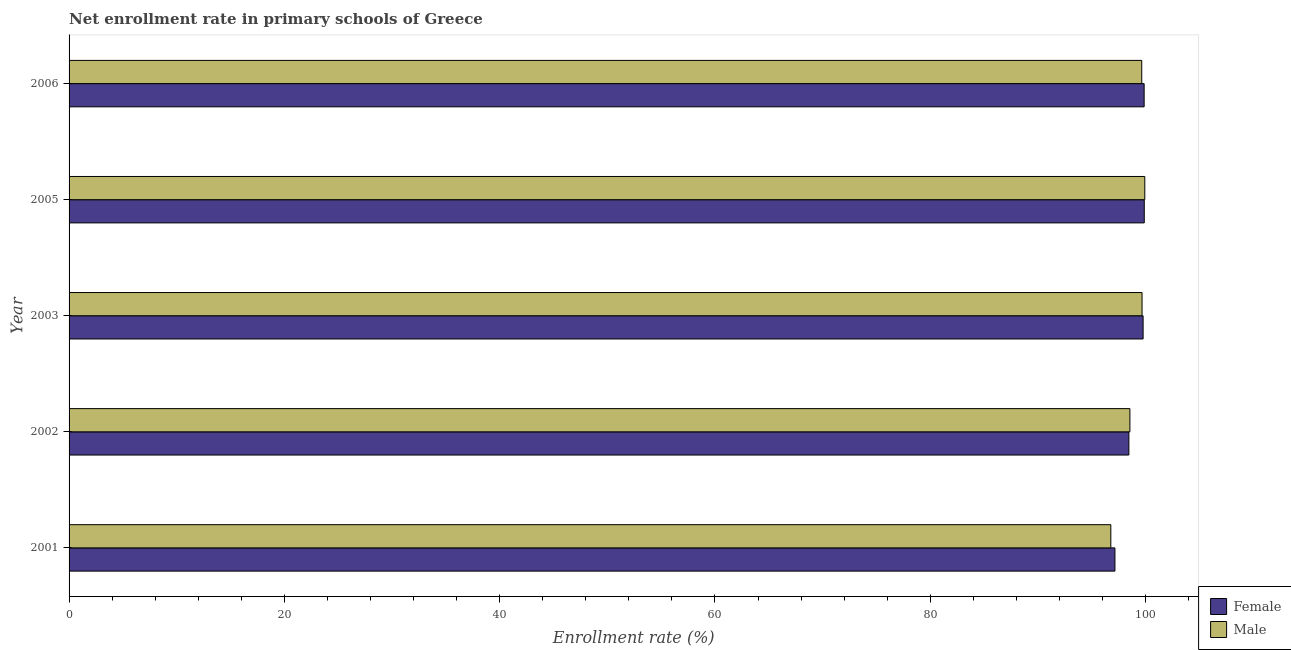How many different coloured bars are there?
Make the answer very short. 2. Are the number of bars on each tick of the Y-axis equal?
Ensure brevity in your answer.  Yes. How many bars are there on the 5th tick from the bottom?
Your response must be concise. 2. What is the label of the 5th group of bars from the top?
Keep it short and to the point. 2001. In how many cases, is the number of bars for a given year not equal to the number of legend labels?
Your response must be concise. 0. What is the enrollment rate of female students in 2005?
Offer a very short reply. 99.88. Across all years, what is the maximum enrollment rate of male students?
Your answer should be compact. 99.93. Across all years, what is the minimum enrollment rate of female students?
Your response must be concise. 97.15. In which year was the enrollment rate of male students minimum?
Your answer should be compact. 2001. What is the total enrollment rate of male students in the graph?
Provide a short and direct response. 494.55. What is the difference between the enrollment rate of female students in 2002 and that in 2005?
Your response must be concise. -1.43. What is the difference between the enrollment rate of male students in 2002 and the enrollment rate of female students in 2005?
Make the answer very short. -1.33. What is the average enrollment rate of female students per year?
Provide a succinct answer. 99.02. In the year 2003, what is the difference between the enrollment rate of female students and enrollment rate of male students?
Give a very brief answer. 0.1. What is the ratio of the enrollment rate of male students in 2003 to that in 2005?
Give a very brief answer. 1. Is the enrollment rate of male students in 2001 less than that in 2003?
Your answer should be very brief. Yes. What is the difference between the highest and the second highest enrollment rate of male students?
Provide a short and direct response. 0.26. What is the difference between the highest and the lowest enrollment rate of male students?
Ensure brevity in your answer.  3.16. In how many years, is the enrollment rate of male students greater than the average enrollment rate of male students taken over all years?
Give a very brief answer. 3. Is the sum of the enrollment rate of female students in 2001 and 2006 greater than the maximum enrollment rate of male students across all years?
Provide a short and direct response. Yes. What does the 2nd bar from the top in 2003 represents?
Give a very brief answer. Female. What does the 2nd bar from the bottom in 2001 represents?
Offer a terse response. Male. How many years are there in the graph?
Make the answer very short. 5. Are the values on the major ticks of X-axis written in scientific E-notation?
Ensure brevity in your answer.  No. Does the graph contain any zero values?
Your answer should be very brief. No. Where does the legend appear in the graph?
Provide a short and direct response. Bottom right. How are the legend labels stacked?
Offer a very short reply. Vertical. What is the title of the graph?
Offer a very short reply. Net enrollment rate in primary schools of Greece. Does "Total Population" appear as one of the legend labels in the graph?
Give a very brief answer. No. What is the label or title of the X-axis?
Give a very brief answer. Enrollment rate (%). What is the Enrollment rate (%) in Female in 2001?
Provide a short and direct response. 97.15. What is the Enrollment rate (%) of Male in 2001?
Offer a terse response. 96.77. What is the Enrollment rate (%) of Female in 2002?
Provide a short and direct response. 98.45. What is the Enrollment rate (%) of Male in 2002?
Your response must be concise. 98.54. What is the Enrollment rate (%) of Female in 2003?
Provide a succinct answer. 99.77. What is the Enrollment rate (%) of Male in 2003?
Your answer should be very brief. 99.67. What is the Enrollment rate (%) of Female in 2005?
Offer a terse response. 99.88. What is the Enrollment rate (%) in Male in 2005?
Keep it short and to the point. 99.93. What is the Enrollment rate (%) of Female in 2006?
Give a very brief answer. 99.87. What is the Enrollment rate (%) in Male in 2006?
Your answer should be very brief. 99.64. Across all years, what is the maximum Enrollment rate (%) of Female?
Your answer should be compact. 99.88. Across all years, what is the maximum Enrollment rate (%) of Male?
Your response must be concise. 99.93. Across all years, what is the minimum Enrollment rate (%) of Female?
Make the answer very short. 97.15. Across all years, what is the minimum Enrollment rate (%) of Male?
Give a very brief answer. 96.77. What is the total Enrollment rate (%) of Female in the graph?
Your answer should be compact. 495.11. What is the total Enrollment rate (%) of Male in the graph?
Keep it short and to the point. 494.55. What is the difference between the Enrollment rate (%) in Female in 2001 and that in 2002?
Give a very brief answer. -1.3. What is the difference between the Enrollment rate (%) in Male in 2001 and that in 2002?
Offer a terse response. -1.77. What is the difference between the Enrollment rate (%) in Female in 2001 and that in 2003?
Ensure brevity in your answer.  -2.62. What is the difference between the Enrollment rate (%) of Male in 2001 and that in 2003?
Your answer should be very brief. -2.9. What is the difference between the Enrollment rate (%) of Female in 2001 and that in 2005?
Ensure brevity in your answer.  -2.72. What is the difference between the Enrollment rate (%) of Male in 2001 and that in 2005?
Your answer should be compact. -3.16. What is the difference between the Enrollment rate (%) of Female in 2001 and that in 2006?
Offer a terse response. -2.71. What is the difference between the Enrollment rate (%) in Male in 2001 and that in 2006?
Your answer should be compact. -2.87. What is the difference between the Enrollment rate (%) in Female in 2002 and that in 2003?
Ensure brevity in your answer.  -1.32. What is the difference between the Enrollment rate (%) of Male in 2002 and that in 2003?
Your response must be concise. -1.13. What is the difference between the Enrollment rate (%) of Female in 2002 and that in 2005?
Make the answer very short. -1.43. What is the difference between the Enrollment rate (%) in Male in 2002 and that in 2005?
Provide a succinct answer. -1.38. What is the difference between the Enrollment rate (%) in Female in 2002 and that in 2006?
Keep it short and to the point. -1.42. What is the difference between the Enrollment rate (%) in Male in 2002 and that in 2006?
Ensure brevity in your answer.  -1.1. What is the difference between the Enrollment rate (%) of Female in 2003 and that in 2005?
Give a very brief answer. -0.11. What is the difference between the Enrollment rate (%) of Male in 2003 and that in 2005?
Offer a very short reply. -0.26. What is the difference between the Enrollment rate (%) of Female in 2003 and that in 2006?
Ensure brevity in your answer.  -0.1. What is the difference between the Enrollment rate (%) in Male in 2003 and that in 2006?
Keep it short and to the point. 0.03. What is the difference between the Enrollment rate (%) in Female in 2005 and that in 2006?
Make the answer very short. 0.01. What is the difference between the Enrollment rate (%) of Male in 2005 and that in 2006?
Offer a very short reply. 0.28. What is the difference between the Enrollment rate (%) in Female in 2001 and the Enrollment rate (%) in Male in 2002?
Give a very brief answer. -1.39. What is the difference between the Enrollment rate (%) of Female in 2001 and the Enrollment rate (%) of Male in 2003?
Offer a very short reply. -2.52. What is the difference between the Enrollment rate (%) of Female in 2001 and the Enrollment rate (%) of Male in 2005?
Make the answer very short. -2.77. What is the difference between the Enrollment rate (%) in Female in 2001 and the Enrollment rate (%) in Male in 2006?
Your answer should be very brief. -2.49. What is the difference between the Enrollment rate (%) in Female in 2002 and the Enrollment rate (%) in Male in 2003?
Offer a terse response. -1.22. What is the difference between the Enrollment rate (%) in Female in 2002 and the Enrollment rate (%) in Male in 2005?
Give a very brief answer. -1.48. What is the difference between the Enrollment rate (%) of Female in 2002 and the Enrollment rate (%) of Male in 2006?
Make the answer very short. -1.2. What is the difference between the Enrollment rate (%) of Female in 2003 and the Enrollment rate (%) of Male in 2005?
Offer a terse response. -0.16. What is the difference between the Enrollment rate (%) of Female in 2003 and the Enrollment rate (%) of Male in 2006?
Keep it short and to the point. 0.13. What is the difference between the Enrollment rate (%) of Female in 2005 and the Enrollment rate (%) of Male in 2006?
Your response must be concise. 0.23. What is the average Enrollment rate (%) of Female per year?
Provide a succinct answer. 99.02. What is the average Enrollment rate (%) of Male per year?
Your answer should be very brief. 98.91. In the year 2001, what is the difference between the Enrollment rate (%) in Female and Enrollment rate (%) in Male?
Your answer should be compact. 0.38. In the year 2002, what is the difference between the Enrollment rate (%) of Female and Enrollment rate (%) of Male?
Offer a terse response. -0.1. In the year 2003, what is the difference between the Enrollment rate (%) in Female and Enrollment rate (%) in Male?
Your answer should be compact. 0.1. In the year 2005, what is the difference between the Enrollment rate (%) in Female and Enrollment rate (%) in Male?
Provide a short and direct response. -0.05. In the year 2006, what is the difference between the Enrollment rate (%) of Female and Enrollment rate (%) of Male?
Provide a short and direct response. 0.22. What is the ratio of the Enrollment rate (%) in Female in 2001 to that in 2003?
Make the answer very short. 0.97. What is the ratio of the Enrollment rate (%) of Male in 2001 to that in 2003?
Your response must be concise. 0.97. What is the ratio of the Enrollment rate (%) in Female in 2001 to that in 2005?
Provide a short and direct response. 0.97. What is the ratio of the Enrollment rate (%) in Male in 2001 to that in 2005?
Offer a terse response. 0.97. What is the ratio of the Enrollment rate (%) of Female in 2001 to that in 2006?
Provide a succinct answer. 0.97. What is the ratio of the Enrollment rate (%) in Male in 2001 to that in 2006?
Provide a short and direct response. 0.97. What is the ratio of the Enrollment rate (%) of Female in 2002 to that in 2003?
Ensure brevity in your answer.  0.99. What is the ratio of the Enrollment rate (%) in Male in 2002 to that in 2003?
Give a very brief answer. 0.99. What is the ratio of the Enrollment rate (%) in Female in 2002 to that in 2005?
Your answer should be very brief. 0.99. What is the ratio of the Enrollment rate (%) in Male in 2002 to that in 2005?
Offer a very short reply. 0.99. What is the ratio of the Enrollment rate (%) in Female in 2002 to that in 2006?
Offer a very short reply. 0.99. What is the ratio of the Enrollment rate (%) of Male in 2002 to that in 2006?
Provide a succinct answer. 0.99. What is the ratio of the Enrollment rate (%) in Female in 2003 to that in 2005?
Offer a terse response. 1. What is the ratio of the Enrollment rate (%) of Male in 2003 to that in 2006?
Your response must be concise. 1. What is the ratio of the Enrollment rate (%) of Female in 2005 to that in 2006?
Make the answer very short. 1. What is the difference between the highest and the second highest Enrollment rate (%) in Female?
Keep it short and to the point. 0.01. What is the difference between the highest and the second highest Enrollment rate (%) of Male?
Offer a terse response. 0.26. What is the difference between the highest and the lowest Enrollment rate (%) of Female?
Make the answer very short. 2.72. What is the difference between the highest and the lowest Enrollment rate (%) of Male?
Offer a terse response. 3.16. 